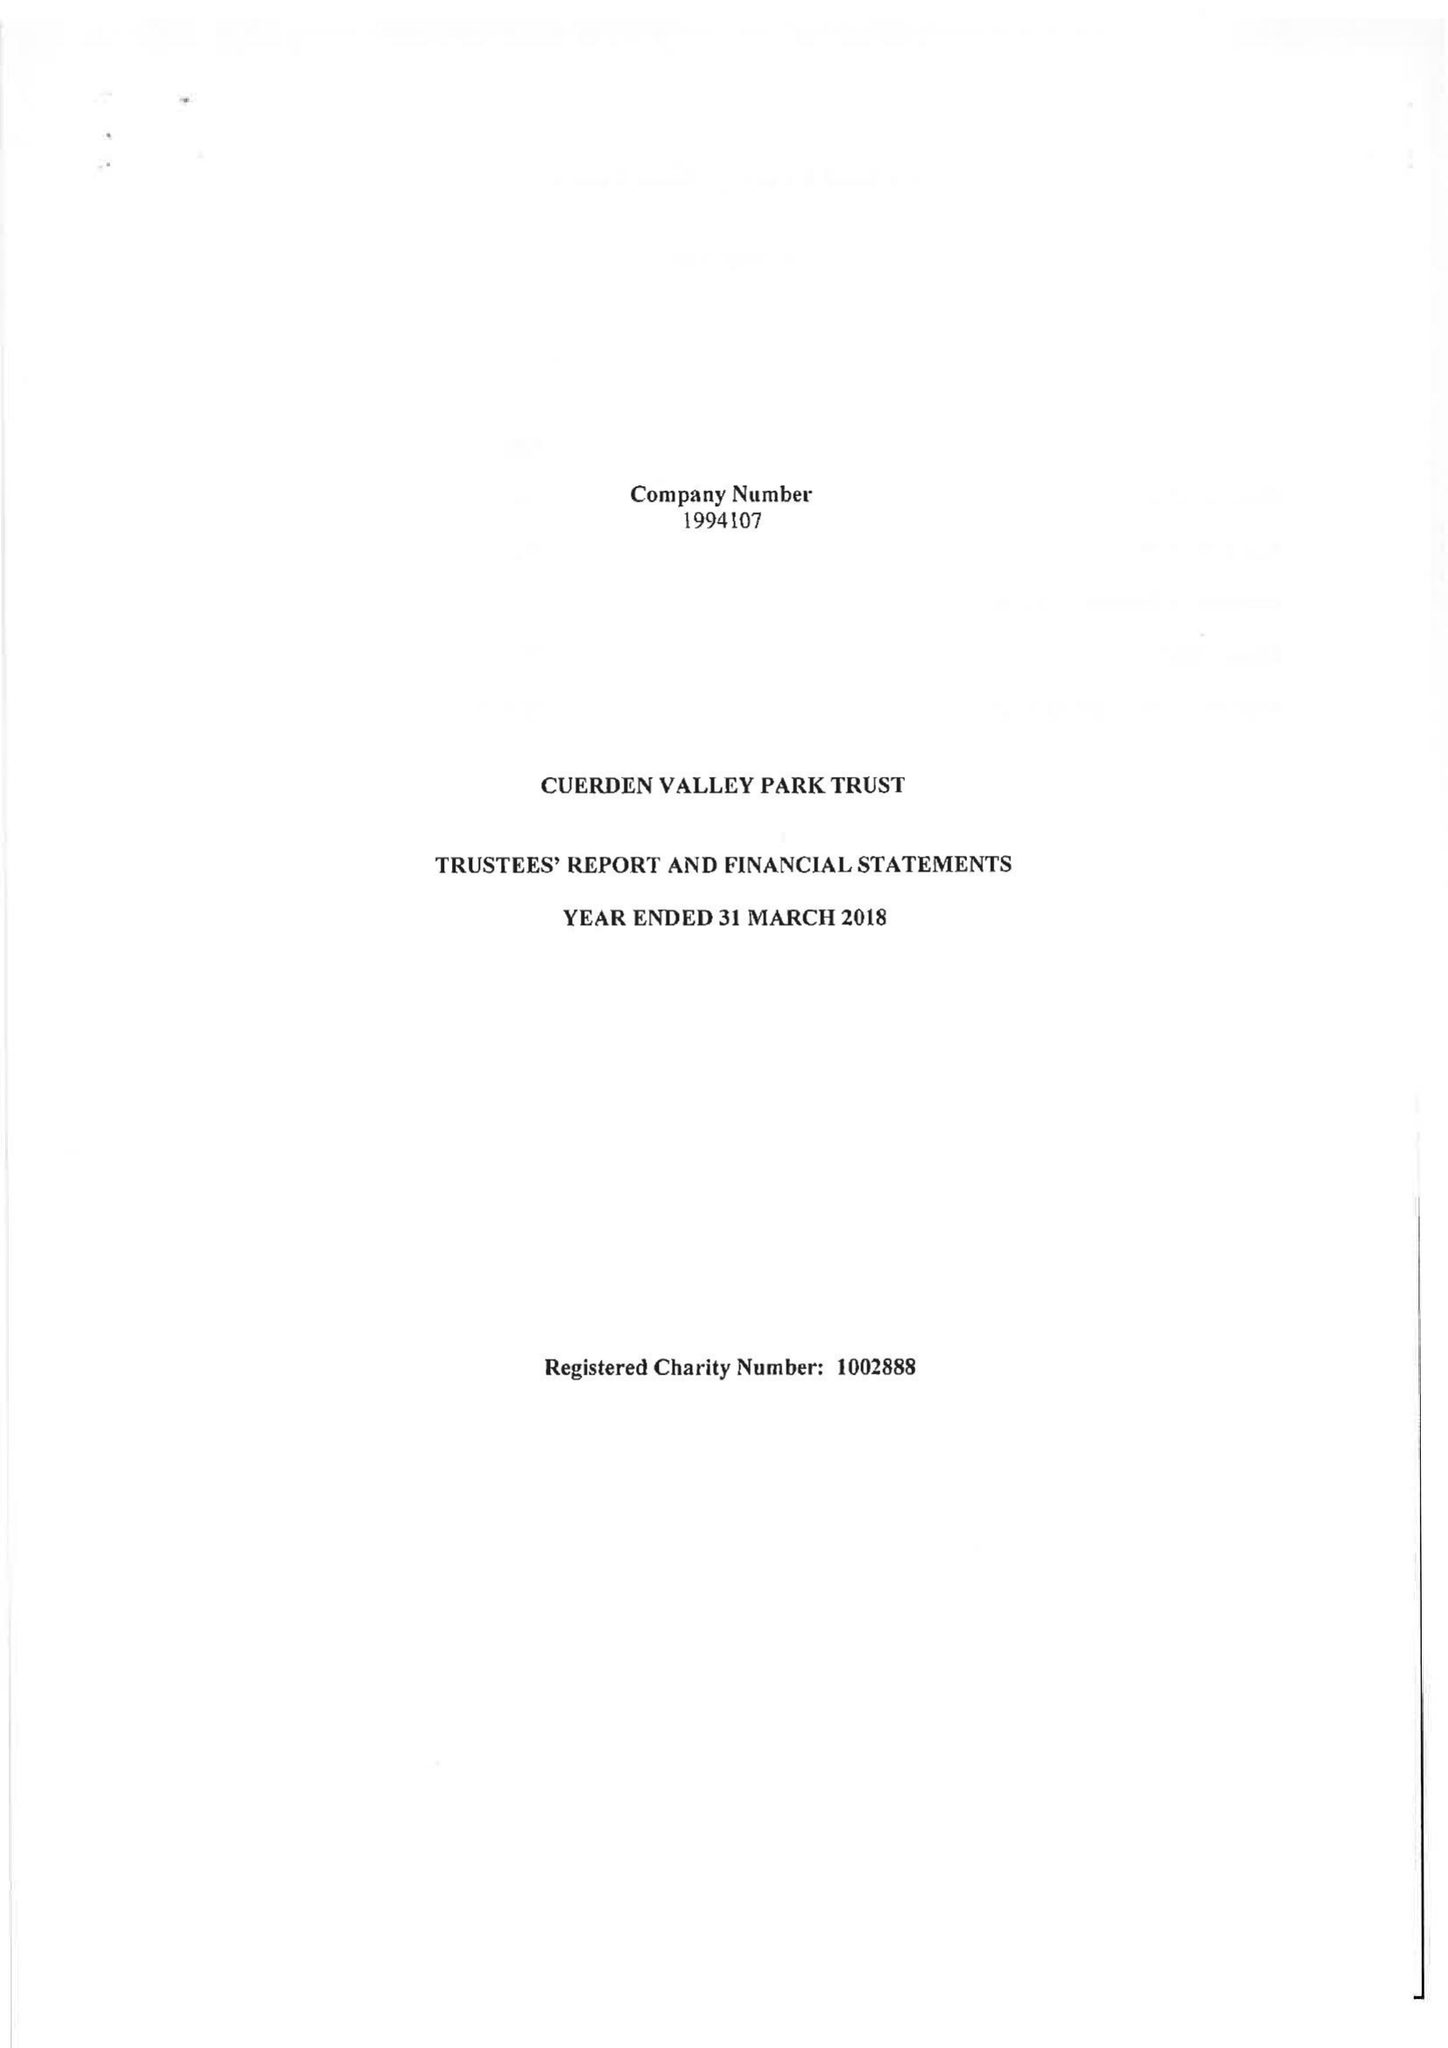What is the value for the charity_number?
Answer the question using a single word or phrase. 1002888 